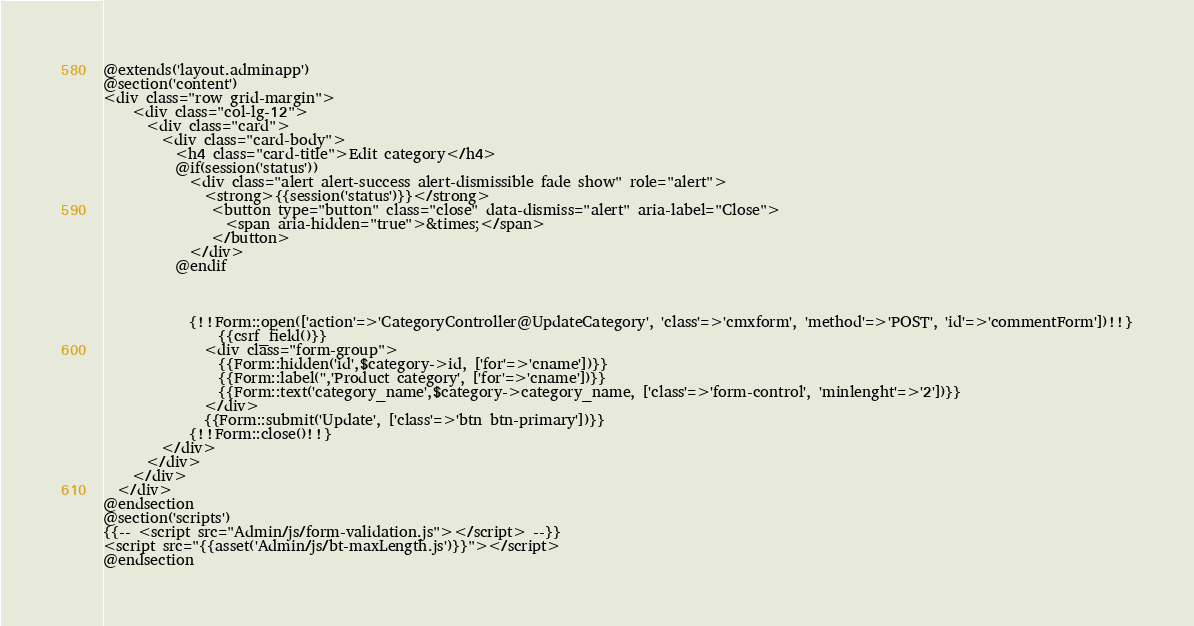<code> <loc_0><loc_0><loc_500><loc_500><_PHP_>@extends('layout.adminapp')
@section('content')
<div class="row grid-margin">
    <div class="col-lg-12">
      <div class="card">
        <div class="card-body">
          <h4 class="card-title">Edit category</h4>
          @if(session('status'))
            <div class="alert alert-success alert-dismissible fade show" role="alert">
              <strong>{{session('status')}}</strong> 
               <button type="button" class="close" data-dismiss="alert" aria-label="Close">
                 <span aria-hidden="true">&times;</span>
               </button>
            </div>
          @endif
          

     
            {!!Form::open(['action'=>'CategoryController@UpdateCategory', 'class'=>'cmxform', 'method'=>'POST', 'id'=>'commentForm'])!!}
                {{csrf_field()}}
              <div class="form-group">
                {{Form::hidden('id',$category->id, ['for'=>'cname'])}}
                {{Form::label('','Product category', ['for'=>'cname'])}}
                {{Form::text('category_name',$category->category_name, ['class'=>'form-control', 'minlenght'=>'2'])}} 
              </div>
              {{Form::submit('Update', ['class'=>'btn btn-primary'])}}
            {!!Form::close()!!} 
        </div>
      </div>
    </div>
  </div>
@endsection
@section('scripts')
{{-- <script src="Admin/js/form-validation.js"></script> --}}
<script src="{{asset('Admin/js/bt-maxLength.js')}}"></script>
@endsection
</code> 